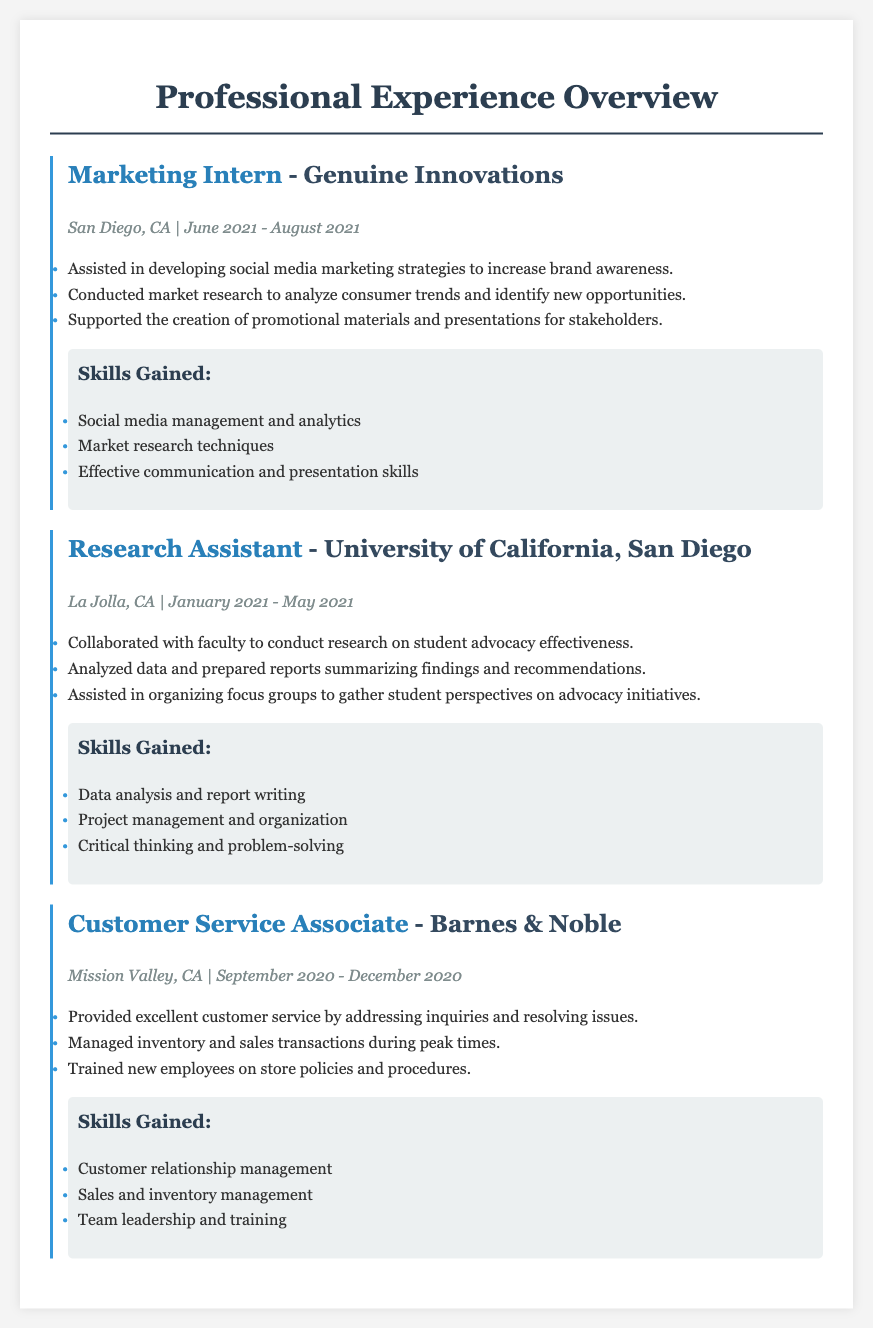What is the title of the first internship? The first internship listed in the document is titled "Marketing Intern".
Answer: Marketing Intern Where did the Marketing Intern work? The document specifies the company name where the Marketing Intern worked as "Genuine Innovations".
Answer: Genuine Innovations What were the dates of the Research Assistant position? The document provides the timeframe for the Research Assistant position as "January 2021 - May 2021".
Answer: January 2021 - May 2021 Which job involved customer service? This job description specifically details responsibilities related to customer service, indicating the position of "Customer Service Associate".
Answer: Customer Service Associate What skills were gained during the Research Assistant internship? The document lists the skills acquired in the research position including "Data analysis and report writing".
Answer: Data analysis and report writing How many months did the Marketing Intern work? The duration of the Marketing Internship is indicated as two months, from June to August.
Answer: Two months What was the primary focus of the research conducted by the Research Assistant? The document states the primary focus as researching "student advocacy effectiveness".
Answer: student advocacy effectiveness Which position required training new employees? The Customer Service Associate role involved training new employees on store policies.
Answer: Customer Service Associate 